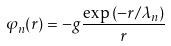<formula> <loc_0><loc_0><loc_500><loc_500>\varphi _ { n } ( r ) = - g \frac { \exp \left ( - r / \lambda _ { n } \right ) } { r }</formula> 